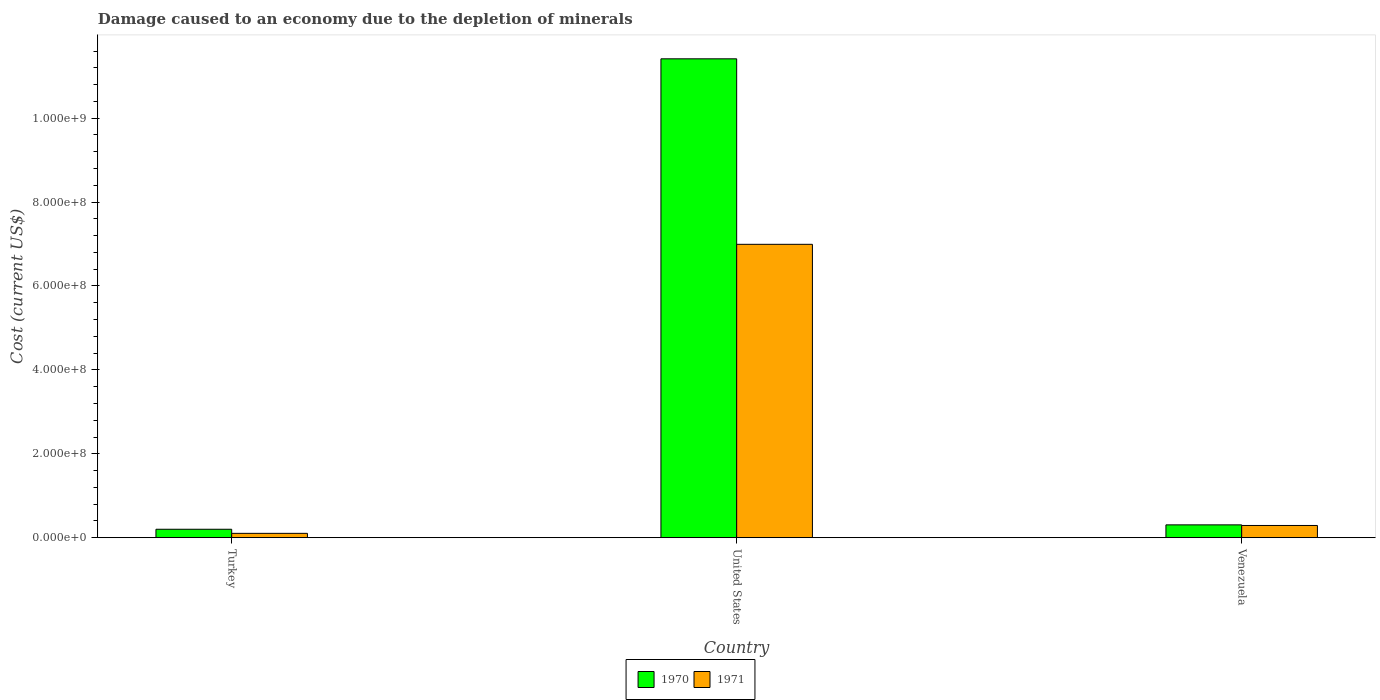What is the label of the 3rd group of bars from the left?
Keep it short and to the point. Venezuela. What is the cost of damage caused due to the depletion of minerals in 1971 in Venezuela?
Your answer should be compact. 2.91e+07. Across all countries, what is the maximum cost of damage caused due to the depletion of minerals in 1970?
Offer a very short reply. 1.14e+09. Across all countries, what is the minimum cost of damage caused due to the depletion of minerals in 1970?
Provide a succinct answer. 2.02e+07. What is the total cost of damage caused due to the depletion of minerals in 1970 in the graph?
Offer a very short reply. 1.19e+09. What is the difference between the cost of damage caused due to the depletion of minerals in 1971 in United States and that in Venezuela?
Provide a short and direct response. 6.70e+08. What is the difference between the cost of damage caused due to the depletion of minerals in 1971 in Turkey and the cost of damage caused due to the depletion of minerals in 1970 in United States?
Keep it short and to the point. -1.13e+09. What is the average cost of damage caused due to the depletion of minerals in 1971 per country?
Give a very brief answer. 2.46e+08. What is the difference between the cost of damage caused due to the depletion of minerals of/in 1970 and cost of damage caused due to the depletion of minerals of/in 1971 in United States?
Offer a very short reply. 4.42e+08. What is the ratio of the cost of damage caused due to the depletion of minerals in 1970 in Turkey to that in Venezuela?
Your answer should be compact. 0.66. Is the cost of damage caused due to the depletion of minerals in 1970 in United States less than that in Venezuela?
Provide a succinct answer. No. Is the difference between the cost of damage caused due to the depletion of minerals in 1970 in United States and Venezuela greater than the difference between the cost of damage caused due to the depletion of minerals in 1971 in United States and Venezuela?
Offer a terse response. Yes. What is the difference between the highest and the second highest cost of damage caused due to the depletion of minerals in 1970?
Your answer should be compact. 1.05e+07. What is the difference between the highest and the lowest cost of damage caused due to the depletion of minerals in 1970?
Your response must be concise. 1.12e+09. Is the sum of the cost of damage caused due to the depletion of minerals in 1971 in Turkey and Venezuela greater than the maximum cost of damage caused due to the depletion of minerals in 1970 across all countries?
Offer a terse response. No. How many countries are there in the graph?
Your answer should be very brief. 3. What is the difference between two consecutive major ticks on the Y-axis?
Provide a short and direct response. 2.00e+08. Are the values on the major ticks of Y-axis written in scientific E-notation?
Ensure brevity in your answer.  Yes. Where does the legend appear in the graph?
Ensure brevity in your answer.  Bottom center. How many legend labels are there?
Keep it short and to the point. 2. How are the legend labels stacked?
Offer a terse response. Horizontal. What is the title of the graph?
Your response must be concise. Damage caused to an economy due to the depletion of minerals. Does "1977" appear as one of the legend labels in the graph?
Keep it short and to the point. No. What is the label or title of the X-axis?
Offer a very short reply. Country. What is the label or title of the Y-axis?
Make the answer very short. Cost (current US$). What is the Cost (current US$) in 1970 in Turkey?
Your answer should be compact. 2.02e+07. What is the Cost (current US$) of 1971 in Turkey?
Your answer should be compact. 1.04e+07. What is the Cost (current US$) in 1970 in United States?
Make the answer very short. 1.14e+09. What is the Cost (current US$) of 1971 in United States?
Keep it short and to the point. 6.99e+08. What is the Cost (current US$) of 1970 in Venezuela?
Ensure brevity in your answer.  3.06e+07. What is the Cost (current US$) in 1971 in Venezuela?
Offer a terse response. 2.91e+07. Across all countries, what is the maximum Cost (current US$) in 1970?
Give a very brief answer. 1.14e+09. Across all countries, what is the maximum Cost (current US$) in 1971?
Offer a terse response. 6.99e+08. Across all countries, what is the minimum Cost (current US$) in 1970?
Your answer should be very brief. 2.02e+07. Across all countries, what is the minimum Cost (current US$) of 1971?
Make the answer very short. 1.04e+07. What is the total Cost (current US$) of 1970 in the graph?
Your answer should be compact. 1.19e+09. What is the total Cost (current US$) in 1971 in the graph?
Give a very brief answer. 7.39e+08. What is the difference between the Cost (current US$) in 1970 in Turkey and that in United States?
Your response must be concise. -1.12e+09. What is the difference between the Cost (current US$) of 1971 in Turkey and that in United States?
Offer a terse response. -6.89e+08. What is the difference between the Cost (current US$) of 1970 in Turkey and that in Venezuela?
Offer a very short reply. -1.05e+07. What is the difference between the Cost (current US$) of 1971 in Turkey and that in Venezuela?
Your answer should be very brief. -1.87e+07. What is the difference between the Cost (current US$) in 1970 in United States and that in Venezuela?
Make the answer very short. 1.11e+09. What is the difference between the Cost (current US$) in 1971 in United States and that in Venezuela?
Your answer should be very brief. 6.70e+08. What is the difference between the Cost (current US$) in 1970 in Turkey and the Cost (current US$) in 1971 in United States?
Provide a short and direct response. -6.79e+08. What is the difference between the Cost (current US$) of 1970 in Turkey and the Cost (current US$) of 1971 in Venezuela?
Make the answer very short. -8.99e+06. What is the difference between the Cost (current US$) of 1970 in United States and the Cost (current US$) of 1971 in Venezuela?
Your answer should be compact. 1.11e+09. What is the average Cost (current US$) of 1970 per country?
Make the answer very short. 3.97e+08. What is the average Cost (current US$) in 1971 per country?
Your answer should be very brief. 2.46e+08. What is the difference between the Cost (current US$) of 1970 and Cost (current US$) of 1971 in Turkey?
Provide a short and direct response. 9.76e+06. What is the difference between the Cost (current US$) of 1970 and Cost (current US$) of 1971 in United States?
Make the answer very short. 4.42e+08. What is the difference between the Cost (current US$) in 1970 and Cost (current US$) in 1971 in Venezuela?
Your answer should be compact. 1.47e+06. What is the ratio of the Cost (current US$) in 1970 in Turkey to that in United States?
Offer a terse response. 0.02. What is the ratio of the Cost (current US$) of 1971 in Turkey to that in United States?
Give a very brief answer. 0.01. What is the ratio of the Cost (current US$) of 1970 in Turkey to that in Venezuela?
Give a very brief answer. 0.66. What is the ratio of the Cost (current US$) of 1971 in Turkey to that in Venezuela?
Make the answer very short. 0.36. What is the ratio of the Cost (current US$) of 1970 in United States to that in Venezuela?
Provide a succinct answer. 37.29. What is the ratio of the Cost (current US$) of 1971 in United States to that in Venezuela?
Your answer should be compact. 23.99. What is the difference between the highest and the second highest Cost (current US$) of 1970?
Your response must be concise. 1.11e+09. What is the difference between the highest and the second highest Cost (current US$) of 1971?
Offer a very short reply. 6.70e+08. What is the difference between the highest and the lowest Cost (current US$) in 1970?
Offer a terse response. 1.12e+09. What is the difference between the highest and the lowest Cost (current US$) in 1971?
Keep it short and to the point. 6.89e+08. 